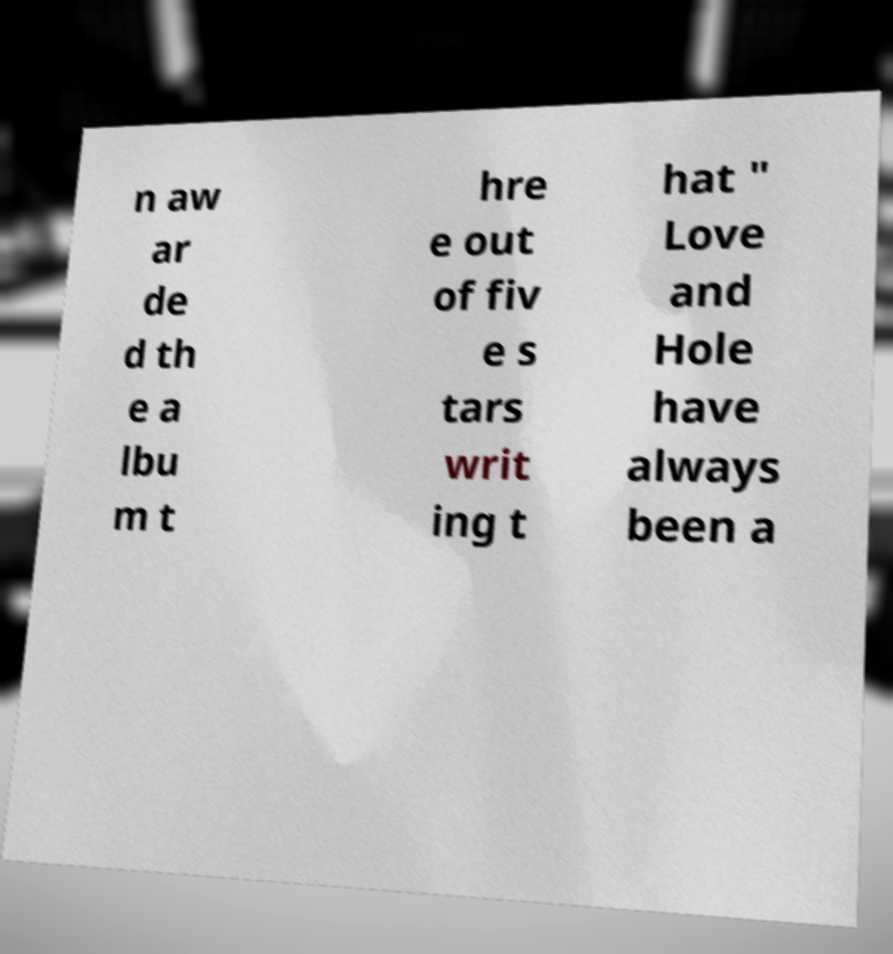Please read and relay the text visible in this image. What does it say? n aw ar de d th e a lbu m t hre e out of fiv e s tars writ ing t hat " Love and Hole have always been a 